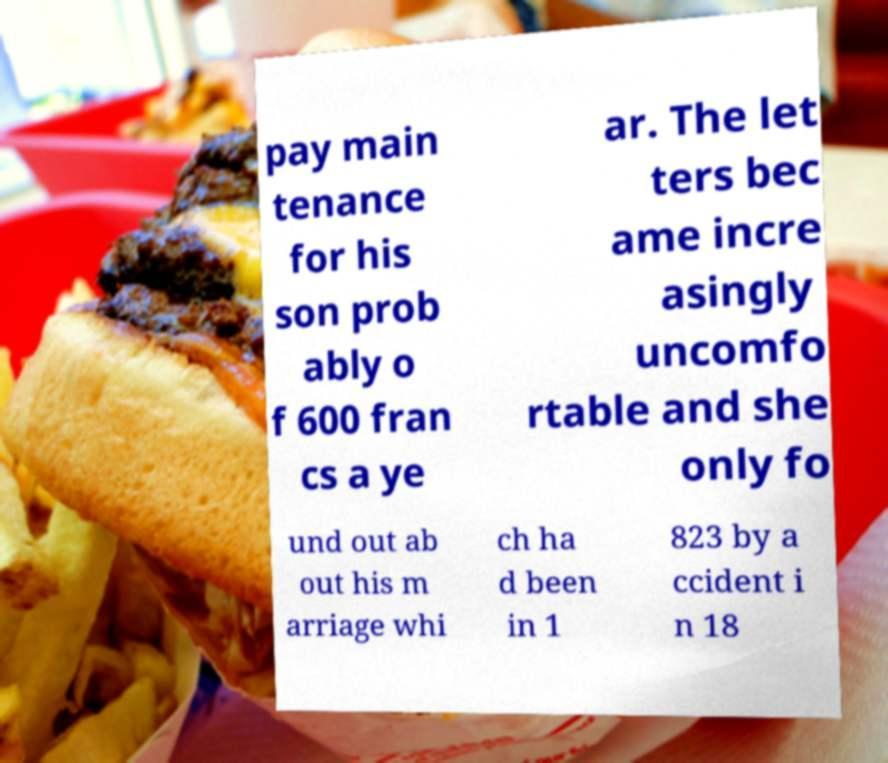Please identify and transcribe the text found in this image. pay main tenance for his son prob ably o f 600 fran cs a ye ar. The let ters bec ame incre asingly uncomfo rtable and she only fo und out ab out his m arriage whi ch ha d been in 1 823 by a ccident i n 18 